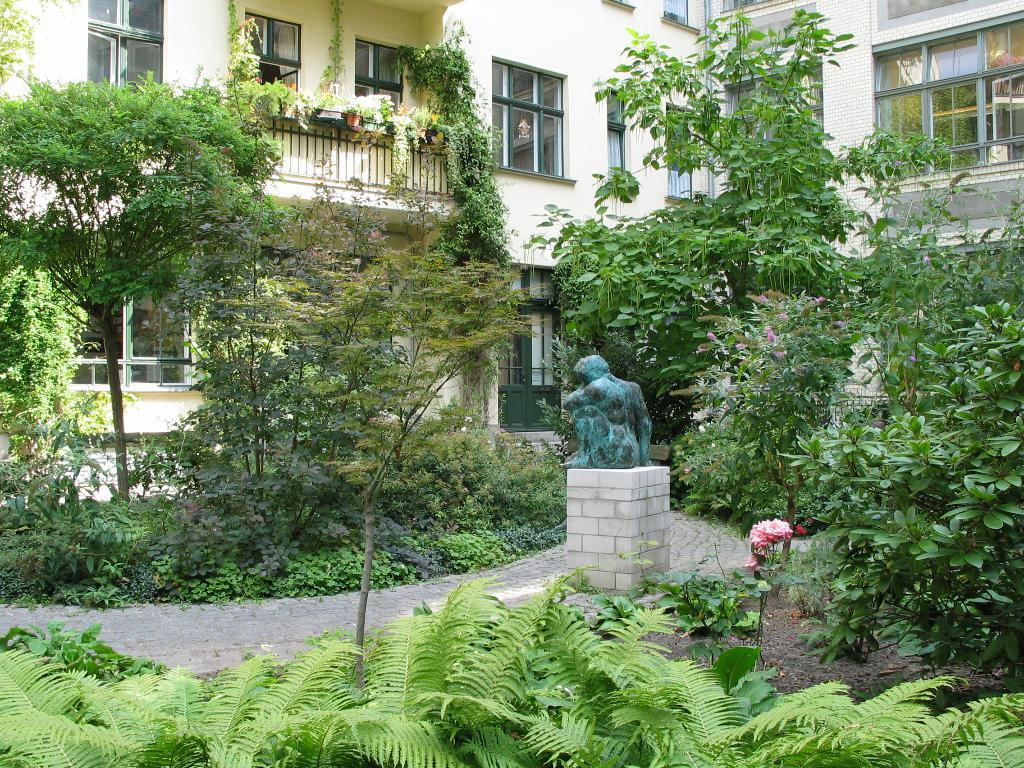What is the main subject in the image? There is a statue in the image. What other elements are present in the image? There are plants, flowers, trees, and a building in the background of the image. What type of tooth can be seen in the image? There is no tooth present in the image. What kind of jewel is adorning the statue in the image? There is no jewel mentioned or visible on the statue in the image. 